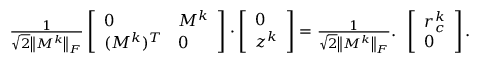<formula> <loc_0><loc_0><loc_500><loc_500>\begin{array} { r } { \frac { 1 } { \sqrt { 2 } \left \| M ^ { k } \right \| _ { F } } \left [ \begin{array} { l l } { 0 } & { M ^ { k } } \\ { ( M ^ { k } ) ^ { T } } & { 0 } \end{array} \right ] \cdot \left [ \begin{array} { l } { 0 } \\ { z ^ { k } } \end{array} \right ] = \frac { 1 } { \sqrt { 2 } \left \| M ^ { k } \right \| _ { F } } . } \end{array} \left [ \begin{array} { l } { r _ { c } ^ { k } } \\ { 0 } \end{array} \right ] .</formula> 